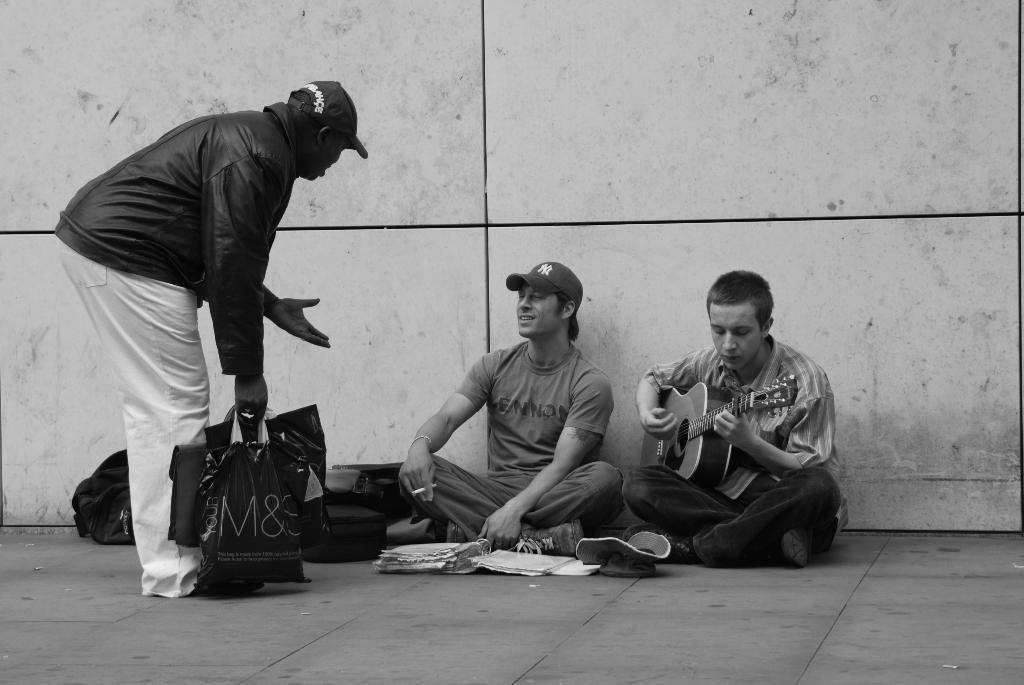In one or two sentences, can you explain what this image depicts? These two persons are sitting and this person playing guitar and this person standing and holding covers and wear cap. We can see bags,books on the road. On the background we can see wall. 